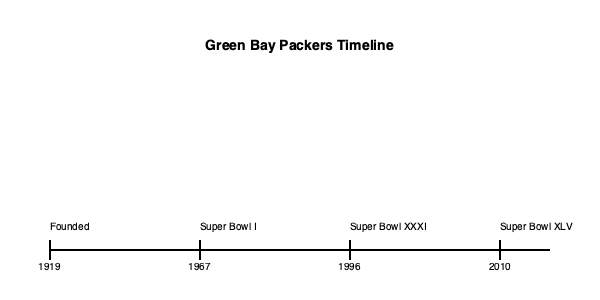According to the timeline, how many years passed between the Packers' first Super Bowl victory and their most recent one shown? To answer this question, we need to follow these steps:

1. Identify the year of the Packers' first Super Bowl victory:
   - The timeline shows Super Bowl I in 1967

2. Identify the year of the Packers' most recent Super Bowl victory shown:
   - The timeline shows Super Bowl XLV in 2010

3. Calculate the difference between these two years:
   2010 - 1967 = 43 years

Therefore, 43 years passed between the Packers' first Super Bowl victory and their most recent one shown on the timeline.
Answer: 43 years 